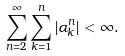<formula> <loc_0><loc_0><loc_500><loc_500>\sum _ { n = 2 } ^ { \infty } \sum _ { k = 1 } ^ { n } | \alpha ^ { n } _ { k } | < \infty .</formula> 